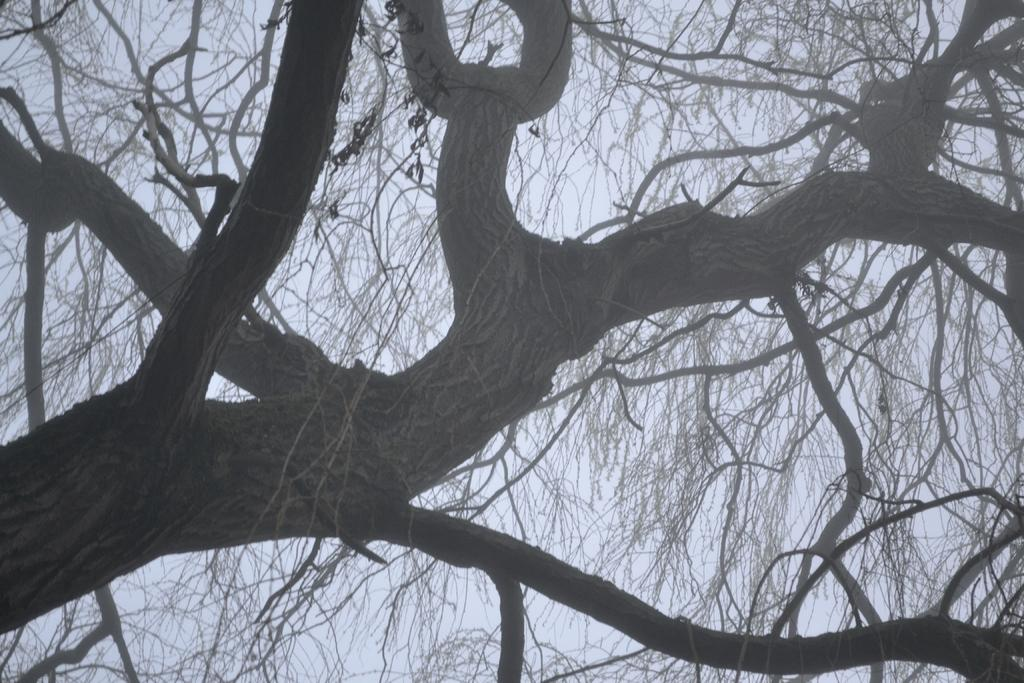What is the main subject of the image? The main subject of the image is the branches of a tree. What is the condition of the tree in the image? The tree has no leaves on it. What caption is written on the branches of the tree in the image? There is no caption written on the branches of the tree in the image. How many books are stacked on the branches of the tree in the image? There are no books present on the branches of the tree in the image. 